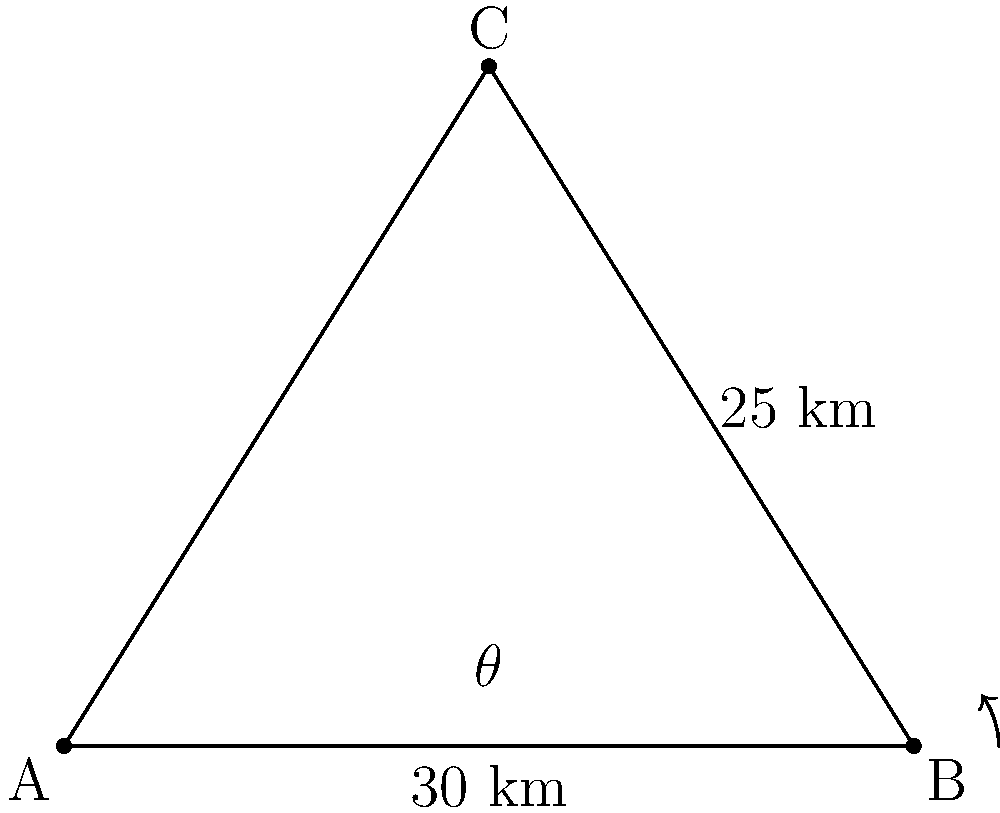A company is planning to build a new data center and needs to determine its optimal location. Three existing data centers form a triangle, with distances between two pairs of centers known. Data center A is 30 km from B, and B is 25 km from C. The angle between AB and BC is 37°. Calculate the distance between data centers A and C to determine the optimal location for the new data center. To solve this problem, we'll use the law of cosines. The law of cosines states that for a triangle with sides a, b, and c, and an angle C opposite side c:

$$c^2 = a^2 + b^2 - 2ab \cos(C)$$

In our case:
- a = 30 km (distance AB)
- b = 25 km (distance BC)
- C = 37° (angle at B)
- c = distance AC (what we're solving for)

Let's plug these values into the formula:

$$c^2 = 30^2 + 25^2 - 2(30)(25) \cos(37°)$$

Step 1: Calculate the squares
$$c^2 = 900 + 625 - 1500 \cos(37°)$$

Step 2: Calculate the cosine
$$\cos(37°) \approx 0.7986$$

Step 3: Multiply
$$c^2 = 900 + 625 - 1500(0.7986) = 1525 - 1197.9 = 327.1$$

Step 4: Take the square root
$$c = \sqrt{327.1} \approx 18.09$$

Therefore, the distance between data centers A and C is approximately 18.09 km.

This information allows the database manager to determine the optimal location for the new data center, considering factors such as network latency, data replication, and disaster recovery planning based on the triangulation of existing centers.
Answer: 18.09 km 